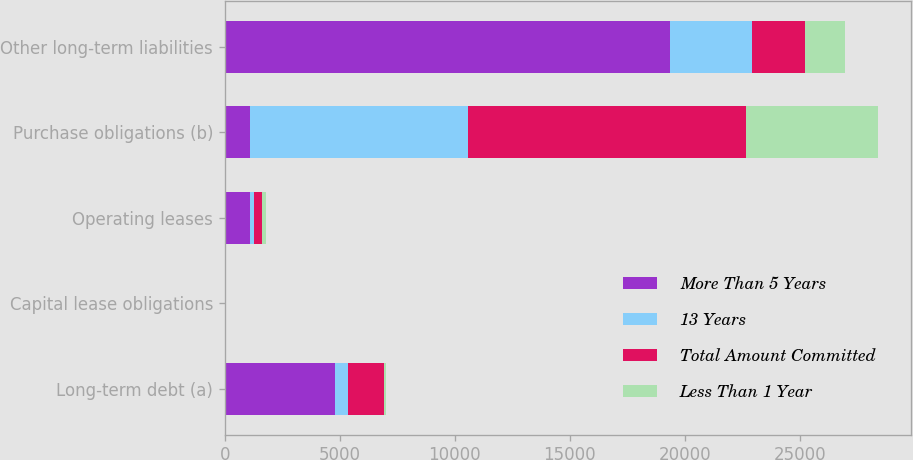Convert chart. <chart><loc_0><loc_0><loc_500><loc_500><stacked_bar_chart><ecel><fcel>Long-term debt (a)<fcel>Capital lease obligations<fcel>Operating leases<fcel>Purchase obligations (b)<fcel>Other long-term liabilities<nl><fcel>More Than 5 Years<fcel>4771<fcel>31<fcel>1078<fcel>1078<fcel>19358<nl><fcel>13 Years<fcel>586<fcel>2<fcel>210<fcel>9482<fcel>3554<nl><fcel>Total Amount Committed<fcel>1549<fcel>4<fcel>313<fcel>12090<fcel>2330<nl><fcel>Less Than 1 Year<fcel>122<fcel>4<fcel>172<fcel>5757<fcel>1705<nl></chart> 